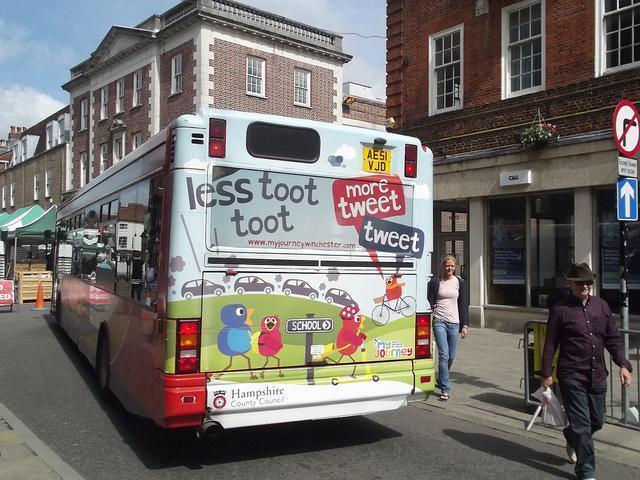Which direction will the bus go next?
Select the accurate answer and provide justification: `Answer: choice
Rationale: srationale.`
Options: Turn right, go straight, turn left, back up. Answer: back up.
Rationale: A bus is stopped because there is a stand in front of it. it will have to go the other way to get out. 